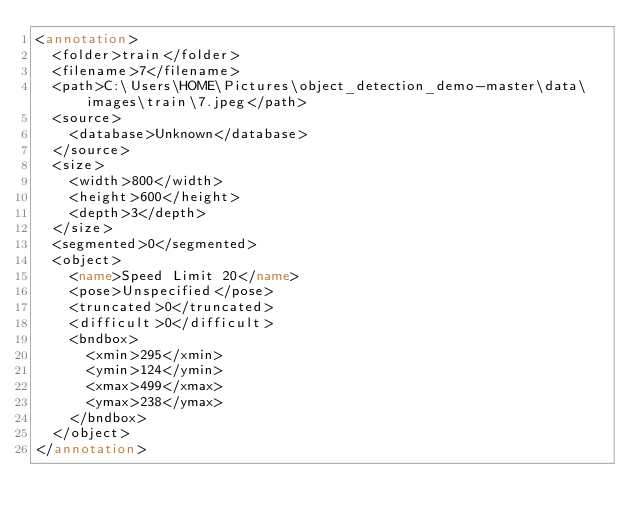<code> <loc_0><loc_0><loc_500><loc_500><_XML_><annotation>
  <folder>train</folder>
  <filename>7</filename>
  <path>C:\Users\HOME\Pictures\object_detection_demo-master\data\images\train\7.jpeg</path>
  <source>
    <database>Unknown</database>
  </source>
  <size>
    <width>800</width>
    <height>600</height>
    <depth>3</depth>
  </size>
  <segmented>0</segmented>
  <object>
    <name>Speed Limit 20</name>
    <pose>Unspecified</pose>
    <truncated>0</truncated>
    <difficult>0</difficult>
    <bndbox>
      <xmin>295</xmin>
      <ymin>124</ymin>
      <xmax>499</xmax>
      <ymax>238</ymax>
    </bndbox>
  </object>
</annotation>
</code> 